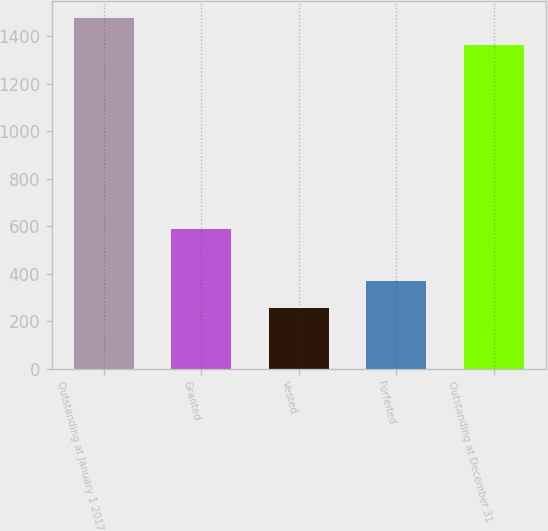<chart> <loc_0><loc_0><loc_500><loc_500><bar_chart><fcel>Outstanding at January 1 2017<fcel>Granted<fcel>Vested<fcel>Forfeited<fcel>Outstanding at December 31<nl><fcel>1474.8<fcel>586<fcel>256<fcel>369.8<fcel>1361<nl></chart> 